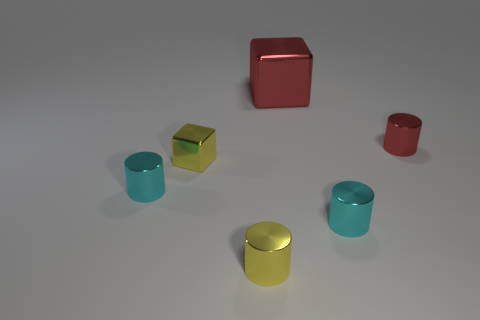Is there any other thing that has the same color as the big metal thing?
Make the answer very short. Yes. What is the size of the red thing that is right of the large red shiny thing?
Your answer should be compact. Small. There is a yellow metal block in front of the red shiny block that is to the right of the small yellow metal thing in front of the tiny yellow cube; how big is it?
Offer a very short reply. Small. What color is the shiny object that is behind the red object on the right side of the large red metallic object?
Offer a very short reply. Red. What material is the small yellow thing that is the same shape as the tiny red object?
Keep it short and to the point. Metal. Are there any other things that are the same material as the red cube?
Offer a terse response. Yes. There is a small yellow shiny block; are there any cyan shiny cylinders behind it?
Offer a very short reply. No. What number of tiny metal blocks are there?
Provide a short and direct response. 1. There is a metallic block that is in front of the small red object; what number of small red metal objects are in front of it?
Provide a succinct answer. 0. Is the color of the large cube the same as the small cube left of the small yellow cylinder?
Make the answer very short. No. 